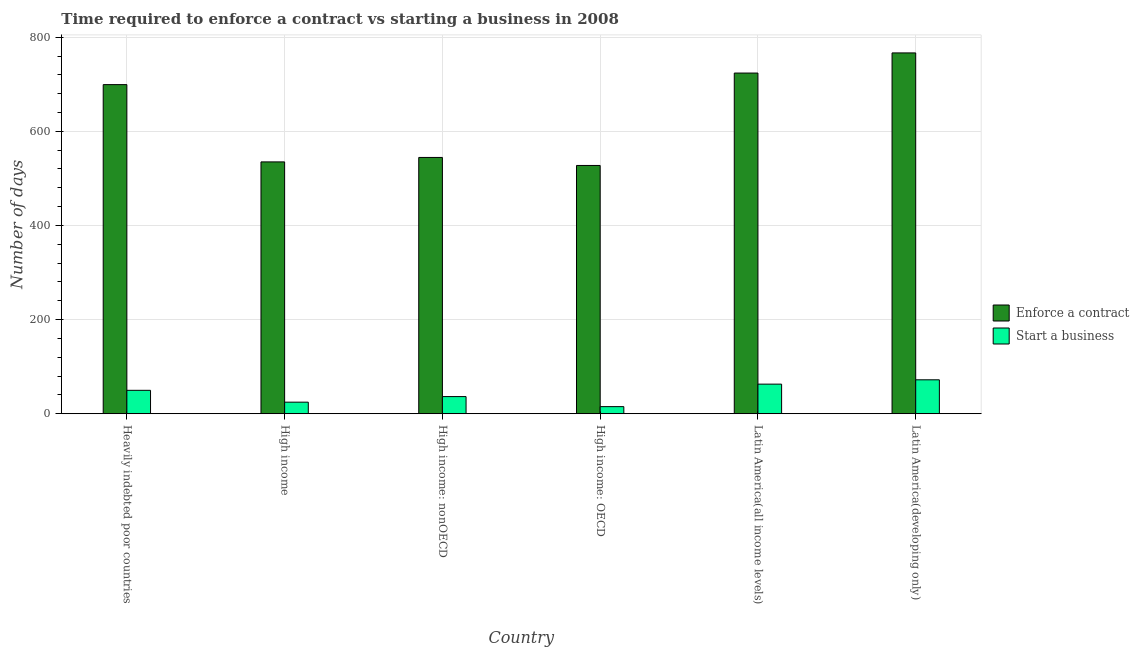How many different coloured bars are there?
Provide a succinct answer. 2. How many groups of bars are there?
Keep it short and to the point. 6. How many bars are there on the 1st tick from the right?
Keep it short and to the point. 2. What is the label of the 3rd group of bars from the left?
Offer a very short reply. High income: nonOECD. In how many cases, is the number of bars for a given country not equal to the number of legend labels?
Your answer should be compact. 0. What is the number of days to start a business in High income: nonOECD?
Your answer should be very brief. 36.44. Across all countries, what is the maximum number of days to start a business?
Give a very brief answer. 72.1. Across all countries, what is the minimum number of days to enforece a contract?
Your response must be concise. 527.47. In which country was the number of days to enforece a contract maximum?
Provide a succinct answer. Latin America(developing only). In which country was the number of days to enforece a contract minimum?
Your response must be concise. High income: OECD. What is the total number of days to start a business in the graph?
Provide a short and direct response. 260.85. What is the difference between the number of days to enforece a contract in High income and that in High income: OECD?
Provide a succinct answer. 7.57. What is the difference between the number of days to start a business in Latin America(all income levels) and the number of days to enforece a contract in High income?
Provide a short and direct response. -472.14. What is the average number of days to start a business per country?
Provide a short and direct response. 43.48. What is the difference between the number of days to enforece a contract and number of days to start a business in Latin America(all income levels)?
Give a very brief answer. 660.9. In how many countries, is the number of days to enforece a contract greater than 120 days?
Provide a short and direct response. 6. What is the ratio of the number of days to enforece a contract in Heavily indebted poor countries to that in High income?
Keep it short and to the point. 1.31. Is the number of days to enforece a contract in Heavily indebted poor countries less than that in High income?
Give a very brief answer. No. What is the difference between the highest and the second highest number of days to enforece a contract?
Offer a terse response. 42.77. What is the difference between the highest and the lowest number of days to enforece a contract?
Your answer should be compact. 239.1. Is the sum of the number of days to enforece a contract in High income and Latin America(all income levels) greater than the maximum number of days to start a business across all countries?
Your answer should be compact. Yes. What does the 1st bar from the left in Heavily indebted poor countries represents?
Make the answer very short. Enforce a contract. What does the 2nd bar from the right in High income represents?
Make the answer very short. Enforce a contract. Are all the bars in the graph horizontal?
Provide a succinct answer. No. How many countries are there in the graph?
Make the answer very short. 6. Does the graph contain any zero values?
Your response must be concise. No. Does the graph contain grids?
Offer a very short reply. Yes. Where does the legend appear in the graph?
Give a very brief answer. Center right. What is the title of the graph?
Offer a terse response. Time required to enforce a contract vs starting a business in 2008. Does "Gasoline" appear as one of the legend labels in the graph?
Offer a terse response. No. What is the label or title of the X-axis?
Your answer should be very brief. Country. What is the label or title of the Y-axis?
Your answer should be compact. Number of days. What is the Number of days in Enforce a contract in Heavily indebted poor countries?
Offer a very short reply. 699.21. What is the Number of days in Start a business in Heavily indebted poor countries?
Offer a terse response. 49.76. What is the Number of days of Enforce a contract in High income?
Ensure brevity in your answer.  535.04. What is the Number of days of Start a business in High income?
Give a very brief answer. 24.57. What is the Number of days of Enforce a contract in High income: nonOECD?
Provide a short and direct response. 544.5. What is the Number of days of Start a business in High income: nonOECD?
Offer a very short reply. 36.44. What is the Number of days of Enforce a contract in High income: OECD?
Offer a terse response. 527.47. What is the Number of days in Start a business in High income: OECD?
Ensure brevity in your answer.  15.08. What is the Number of days in Enforce a contract in Latin America(all income levels)?
Provide a succinct answer. 723.8. What is the Number of days in Start a business in Latin America(all income levels)?
Keep it short and to the point. 62.9. What is the Number of days in Enforce a contract in Latin America(developing only)?
Provide a succinct answer. 766.57. What is the Number of days of Start a business in Latin America(developing only)?
Give a very brief answer. 72.1. Across all countries, what is the maximum Number of days in Enforce a contract?
Your answer should be very brief. 766.57. Across all countries, what is the maximum Number of days of Start a business?
Your answer should be very brief. 72.1. Across all countries, what is the minimum Number of days of Enforce a contract?
Your answer should be compact. 527.47. Across all countries, what is the minimum Number of days of Start a business?
Offer a very short reply. 15.08. What is the total Number of days of Enforce a contract in the graph?
Your answer should be very brief. 3796.59. What is the total Number of days in Start a business in the graph?
Your answer should be very brief. 260.85. What is the difference between the Number of days of Enforce a contract in Heavily indebted poor countries and that in High income?
Your answer should be very brief. 164.17. What is the difference between the Number of days of Start a business in Heavily indebted poor countries and that in High income?
Keep it short and to the point. 25.19. What is the difference between the Number of days in Enforce a contract in Heavily indebted poor countries and that in High income: nonOECD?
Your response must be concise. 154.71. What is the difference between the Number of days in Start a business in Heavily indebted poor countries and that in High income: nonOECD?
Keep it short and to the point. 13.33. What is the difference between the Number of days in Enforce a contract in Heavily indebted poor countries and that in High income: OECD?
Ensure brevity in your answer.  171.74. What is the difference between the Number of days of Start a business in Heavily indebted poor countries and that in High income: OECD?
Your answer should be compact. 34.68. What is the difference between the Number of days of Enforce a contract in Heavily indebted poor countries and that in Latin America(all income levels)?
Offer a terse response. -24.59. What is the difference between the Number of days of Start a business in Heavily indebted poor countries and that in Latin America(all income levels)?
Your answer should be compact. -13.14. What is the difference between the Number of days in Enforce a contract in Heavily indebted poor countries and that in Latin America(developing only)?
Provide a succinct answer. -67.36. What is the difference between the Number of days of Start a business in Heavily indebted poor countries and that in Latin America(developing only)?
Ensure brevity in your answer.  -22.33. What is the difference between the Number of days in Enforce a contract in High income and that in High income: nonOECD?
Provide a short and direct response. -9.46. What is the difference between the Number of days of Start a business in High income and that in High income: nonOECD?
Ensure brevity in your answer.  -11.86. What is the difference between the Number of days of Enforce a contract in High income and that in High income: OECD?
Ensure brevity in your answer.  7.57. What is the difference between the Number of days in Start a business in High income and that in High income: OECD?
Your answer should be compact. 9.49. What is the difference between the Number of days in Enforce a contract in High income and that in Latin America(all income levels)?
Your answer should be compact. -188.76. What is the difference between the Number of days in Start a business in High income and that in Latin America(all income levels)?
Provide a succinct answer. -38.33. What is the difference between the Number of days of Enforce a contract in High income and that in Latin America(developing only)?
Your answer should be compact. -231.53. What is the difference between the Number of days in Start a business in High income and that in Latin America(developing only)?
Offer a very short reply. -47.52. What is the difference between the Number of days in Enforce a contract in High income: nonOECD and that in High income: OECD?
Your response must be concise. 17.03. What is the difference between the Number of days of Start a business in High income: nonOECD and that in High income: OECD?
Your answer should be compact. 21.35. What is the difference between the Number of days in Enforce a contract in High income: nonOECD and that in Latin America(all income levels)?
Provide a succinct answer. -179.3. What is the difference between the Number of days in Start a business in High income: nonOECD and that in Latin America(all income levels)?
Your answer should be compact. -26.46. What is the difference between the Number of days of Enforce a contract in High income: nonOECD and that in Latin America(developing only)?
Give a very brief answer. -222.07. What is the difference between the Number of days in Start a business in High income: nonOECD and that in Latin America(developing only)?
Your response must be concise. -35.66. What is the difference between the Number of days of Enforce a contract in High income: OECD and that in Latin America(all income levels)?
Ensure brevity in your answer.  -196.33. What is the difference between the Number of days in Start a business in High income: OECD and that in Latin America(all income levels)?
Offer a very short reply. -47.82. What is the difference between the Number of days in Enforce a contract in High income: OECD and that in Latin America(developing only)?
Keep it short and to the point. -239.1. What is the difference between the Number of days of Start a business in High income: OECD and that in Latin America(developing only)?
Make the answer very short. -57.01. What is the difference between the Number of days in Enforce a contract in Latin America(all income levels) and that in Latin America(developing only)?
Offer a terse response. -42.77. What is the difference between the Number of days in Start a business in Latin America(all income levels) and that in Latin America(developing only)?
Your answer should be very brief. -9.2. What is the difference between the Number of days of Enforce a contract in Heavily indebted poor countries and the Number of days of Start a business in High income?
Your answer should be very brief. 674.64. What is the difference between the Number of days of Enforce a contract in Heavily indebted poor countries and the Number of days of Start a business in High income: nonOECD?
Keep it short and to the point. 662.77. What is the difference between the Number of days of Enforce a contract in Heavily indebted poor countries and the Number of days of Start a business in High income: OECD?
Provide a short and direct response. 684.13. What is the difference between the Number of days of Enforce a contract in Heavily indebted poor countries and the Number of days of Start a business in Latin America(all income levels)?
Your response must be concise. 636.31. What is the difference between the Number of days in Enforce a contract in Heavily indebted poor countries and the Number of days in Start a business in Latin America(developing only)?
Give a very brief answer. 627.12. What is the difference between the Number of days in Enforce a contract in High income and the Number of days in Start a business in High income: nonOECD?
Your answer should be compact. 498.6. What is the difference between the Number of days of Enforce a contract in High income and the Number of days of Start a business in High income: OECD?
Offer a very short reply. 519.95. What is the difference between the Number of days of Enforce a contract in High income and the Number of days of Start a business in Latin America(all income levels)?
Keep it short and to the point. 472.14. What is the difference between the Number of days of Enforce a contract in High income and the Number of days of Start a business in Latin America(developing only)?
Your answer should be compact. 462.94. What is the difference between the Number of days in Enforce a contract in High income: nonOECD and the Number of days in Start a business in High income: OECD?
Offer a very short reply. 529.42. What is the difference between the Number of days of Enforce a contract in High income: nonOECD and the Number of days of Start a business in Latin America(all income levels)?
Provide a succinct answer. 481.6. What is the difference between the Number of days in Enforce a contract in High income: nonOECD and the Number of days in Start a business in Latin America(developing only)?
Your answer should be compact. 472.4. What is the difference between the Number of days of Enforce a contract in High income: OECD and the Number of days of Start a business in Latin America(all income levels)?
Keep it short and to the point. 464.57. What is the difference between the Number of days of Enforce a contract in High income: OECD and the Number of days of Start a business in Latin America(developing only)?
Your response must be concise. 455.37. What is the difference between the Number of days of Enforce a contract in Latin America(all income levels) and the Number of days of Start a business in Latin America(developing only)?
Ensure brevity in your answer.  651.7. What is the average Number of days of Enforce a contract per country?
Your response must be concise. 632.76. What is the average Number of days of Start a business per country?
Make the answer very short. 43.48. What is the difference between the Number of days in Enforce a contract and Number of days in Start a business in Heavily indebted poor countries?
Your answer should be very brief. 649.45. What is the difference between the Number of days of Enforce a contract and Number of days of Start a business in High income?
Offer a terse response. 510.46. What is the difference between the Number of days in Enforce a contract and Number of days in Start a business in High income: nonOECD?
Make the answer very short. 508.06. What is the difference between the Number of days of Enforce a contract and Number of days of Start a business in High income: OECD?
Ensure brevity in your answer.  512.38. What is the difference between the Number of days in Enforce a contract and Number of days in Start a business in Latin America(all income levels)?
Keep it short and to the point. 660.9. What is the difference between the Number of days of Enforce a contract and Number of days of Start a business in Latin America(developing only)?
Your response must be concise. 694.48. What is the ratio of the Number of days in Enforce a contract in Heavily indebted poor countries to that in High income?
Your answer should be very brief. 1.31. What is the ratio of the Number of days of Start a business in Heavily indebted poor countries to that in High income?
Offer a terse response. 2.02. What is the ratio of the Number of days in Enforce a contract in Heavily indebted poor countries to that in High income: nonOECD?
Your answer should be compact. 1.28. What is the ratio of the Number of days of Start a business in Heavily indebted poor countries to that in High income: nonOECD?
Provide a succinct answer. 1.37. What is the ratio of the Number of days in Enforce a contract in Heavily indebted poor countries to that in High income: OECD?
Offer a very short reply. 1.33. What is the ratio of the Number of days of Start a business in Heavily indebted poor countries to that in High income: OECD?
Give a very brief answer. 3.3. What is the ratio of the Number of days of Start a business in Heavily indebted poor countries to that in Latin America(all income levels)?
Make the answer very short. 0.79. What is the ratio of the Number of days of Enforce a contract in Heavily indebted poor countries to that in Latin America(developing only)?
Provide a short and direct response. 0.91. What is the ratio of the Number of days in Start a business in Heavily indebted poor countries to that in Latin America(developing only)?
Offer a terse response. 0.69. What is the ratio of the Number of days in Enforce a contract in High income to that in High income: nonOECD?
Ensure brevity in your answer.  0.98. What is the ratio of the Number of days in Start a business in High income to that in High income: nonOECD?
Give a very brief answer. 0.67. What is the ratio of the Number of days of Enforce a contract in High income to that in High income: OECD?
Make the answer very short. 1.01. What is the ratio of the Number of days of Start a business in High income to that in High income: OECD?
Keep it short and to the point. 1.63. What is the ratio of the Number of days of Enforce a contract in High income to that in Latin America(all income levels)?
Make the answer very short. 0.74. What is the ratio of the Number of days of Start a business in High income to that in Latin America(all income levels)?
Keep it short and to the point. 0.39. What is the ratio of the Number of days of Enforce a contract in High income to that in Latin America(developing only)?
Keep it short and to the point. 0.7. What is the ratio of the Number of days in Start a business in High income to that in Latin America(developing only)?
Provide a succinct answer. 0.34. What is the ratio of the Number of days of Enforce a contract in High income: nonOECD to that in High income: OECD?
Your response must be concise. 1.03. What is the ratio of the Number of days of Start a business in High income: nonOECD to that in High income: OECD?
Your answer should be very brief. 2.42. What is the ratio of the Number of days of Enforce a contract in High income: nonOECD to that in Latin America(all income levels)?
Offer a very short reply. 0.75. What is the ratio of the Number of days of Start a business in High income: nonOECD to that in Latin America(all income levels)?
Offer a terse response. 0.58. What is the ratio of the Number of days in Enforce a contract in High income: nonOECD to that in Latin America(developing only)?
Your response must be concise. 0.71. What is the ratio of the Number of days of Start a business in High income: nonOECD to that in Latin America(developing only)?
Offer a very short reply. 0.51. What is the ratio of the Number of days in Enforce a contract in High income: OECD to that in Latin America(all income levels)?
Provide a succinct answer. 0.73. What is the ratio of the Number of days in Start a business in High income: OECD to that in Latin America(all income levels)?
Provide a short and direct response. 0.24. What is the ratio of the Number of days of Enforce a contract in High income: OECD to that in Latin America(developing only)?
Your answer should be very brief. 0.69. What is the ratio of the Number of days of Start a business in High income: OECD to that in Latin America(developing only)?
Provide a short and direct response. 0.21. What is the ratio of the Number of days in Enforce a contract in Latin America(all income levels) to that in Latin America(developing only)?
Your answer should be compact. 0.94. What is the ratio of the Number of days of Start a business in Latin America(all income levels) to that in Latin America(developing only)?
Provide a succinct answer. 0.87. What is the difference between the highest and the second highest Number of days in Enforce a contract?
Make the answer very short. 42.77. What is the difference between the highest and the second highest Number of days in Start a business?
Provide a succinct answer. 9.2. What is the difference between the highest and the lowest Number of days of Enforce a contract?
Your response must be concise. 239.1. What is the difference between the highest and the lowest Number of days of Start a business?
Give a very brief answer. 57.01. 